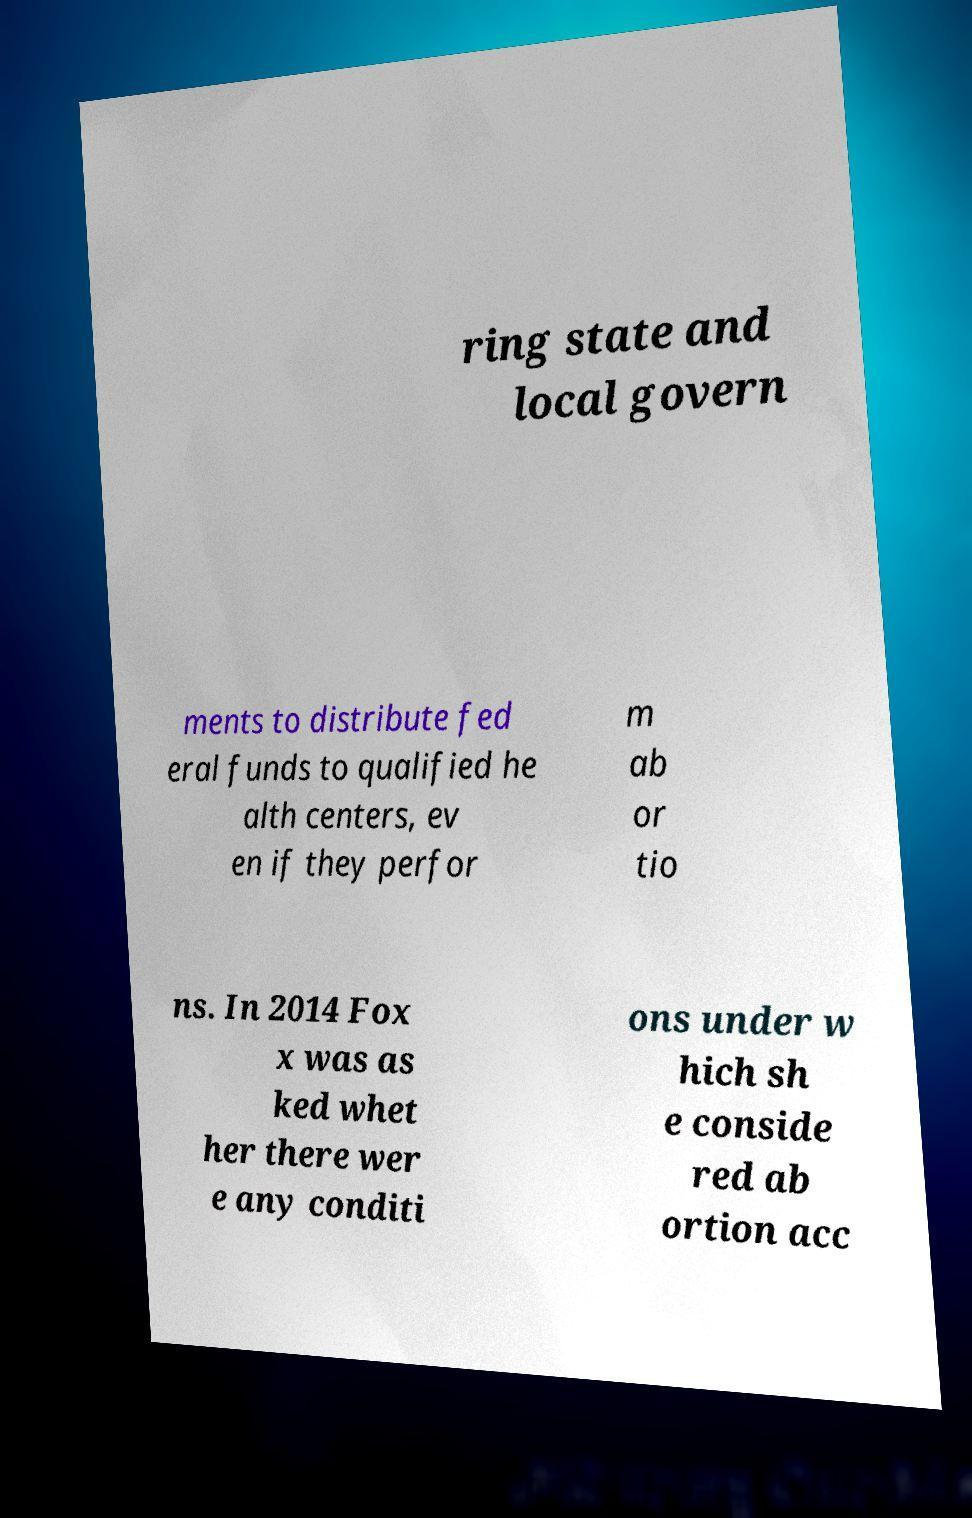I need the written content from this picture converted into text. Can you do that? ring state and local govern ments to distribute fed eral funds to qualified he alth centers, ev en if they perfor m ab or tio ns. In 2014 Fox x was as ked whet her there wer e any conditi ons under w hich sh e conside red ab ortion acc 